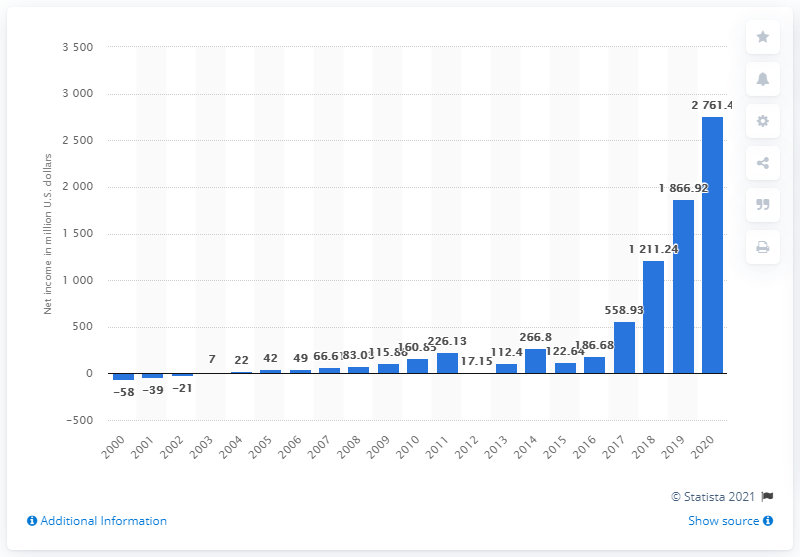Specify some key components in this picture. Netflix's net income in the United States in 2020 was 2761.4 million dollars. 